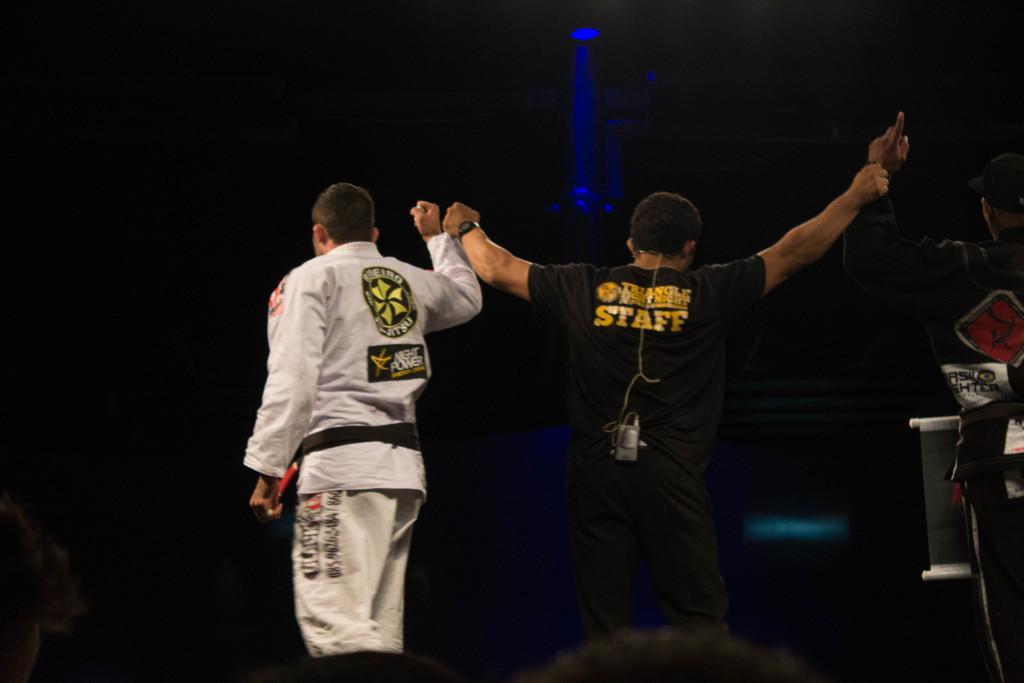What does it say in capital letters on the black t-shirt?
Your response must be concise. Staff. 